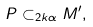<formula> <loc_0><loc_0><loc_500><loc_500>P \subset _ { 2 k \alpha } M ^ { \prime } ,</formula> 